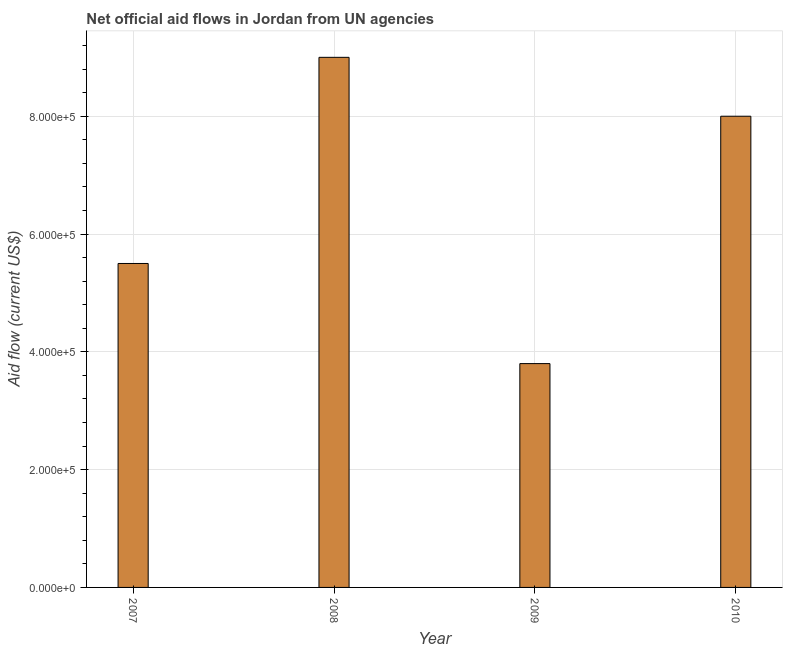What is the title of the graph?
Your answer should be very brief. Net official aid flows in Jordan from UN agencies. What is the label or title of the X-axis?
Provide a short and direct response. Year. Across all years, what is the maximum net official flows from un agencies?
Ensure brevity in your answer.  9.00e+05. In which year was the net official flows from un agencies minimum?
Offer a very short reply. 2009. What is the sum of the net official flows from un agencies?
Ensure brevity in your answer.  2.63e+06. What is the average net official flows from un agencies per year?
Give a very brief answer. 6.58e+05. What is the median net official flows from un agencies?
Your answer should be compact. 6.75e+05. In how many years, is the net official flows from un agencies greater than 880000 US$?
Provide a short and direct response. 1. Do a majority of the years between 2008 and 2007 (inclusive) have net official flows from un agencies greater than 800000 US$?
Make the answer very short. No. Is the net official flows from un agencies in 2008 less than that in 2010?
Ensure brevity in your answer.  No. Is the difference between the net official flows from un agencies in 2007 and 2009 greater than the difference between any two years?
Offer a terse response. No. What is the difference between the highest and the lowest net official flows from un agencies?
Provide a succinct answer. 5.20e+05. In how many years, is the net official flows from un agencies greater than the average net official flows from un agencies taken over all years?
Provide a short and direct response. 2. How many bars are there?
Give a very brief answer. 4. What is the Aid flow (current US$) in 2008?
Give a very brief answer. 9.00e+05. What is the difference between the Aid flow (current US$) in 2007 and 2008?
Provide a short and direct response. -3.50e+05. What is the difference between the Aid flow (current US$) in 2007 and 2010?
Give a very brief answer. -2.50e+05. What is the difference between the Aid flow (current US$) in 2008 and 2009?
Ensure brevity in your answer.  5.20e+05. What is the difference between the Aid flow (current US$) in 2008 and 2010?
Ensure brevity in your answer.  1.00e+05. What is the difference between the Aid flow (current US$) in 2009 and 2010?
Provide a short and direct response. -4.20e+05. What is the ratio of the Aid flow (current US$) in 2007 to that in 2008?
Provide a succinct answer. 0.61. What is the ratio of the Aid flow (current US$) in 2007 to that in 2009?
Give a very brief answer. 1.45. What is the ratio of the Aid flow (current US$) in 2007 to that in 2010?
Provide a short and direct response. 0.69. What is the ratio of the Aid flow (current US$) in 2008 to that in 2009?
Ensure brevity in your answer.  2.37. What is the ratio of the Aid flow (current US$) in 2009 to that in 2010?
Offer a very short reply. 0.47. 